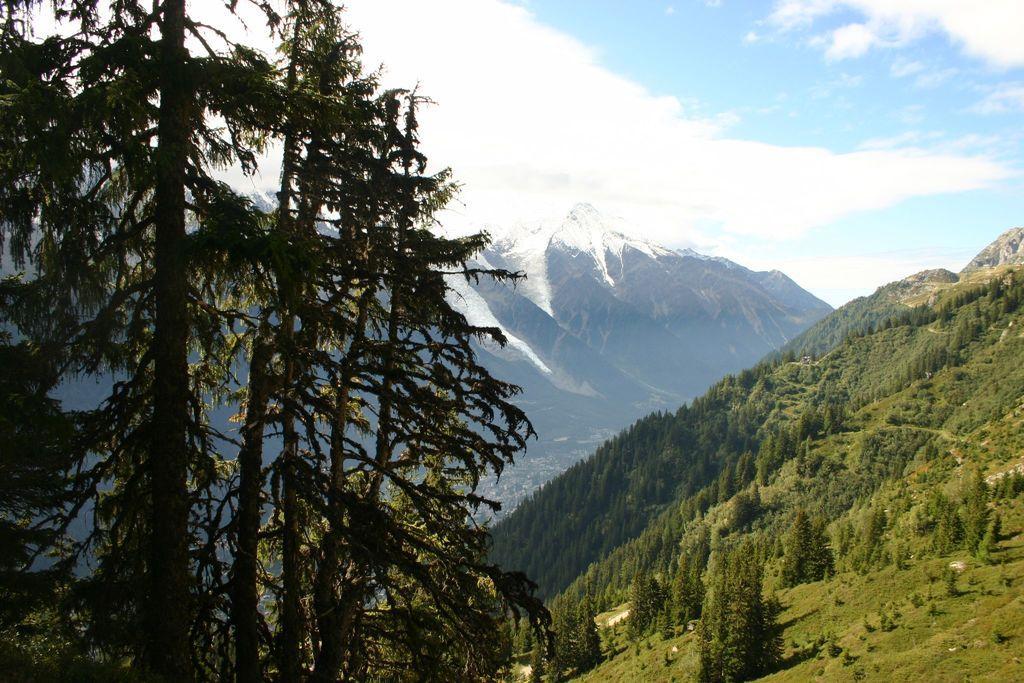How would you summarize this image in a sentence or two? In this picture I can see some trees and hills. 